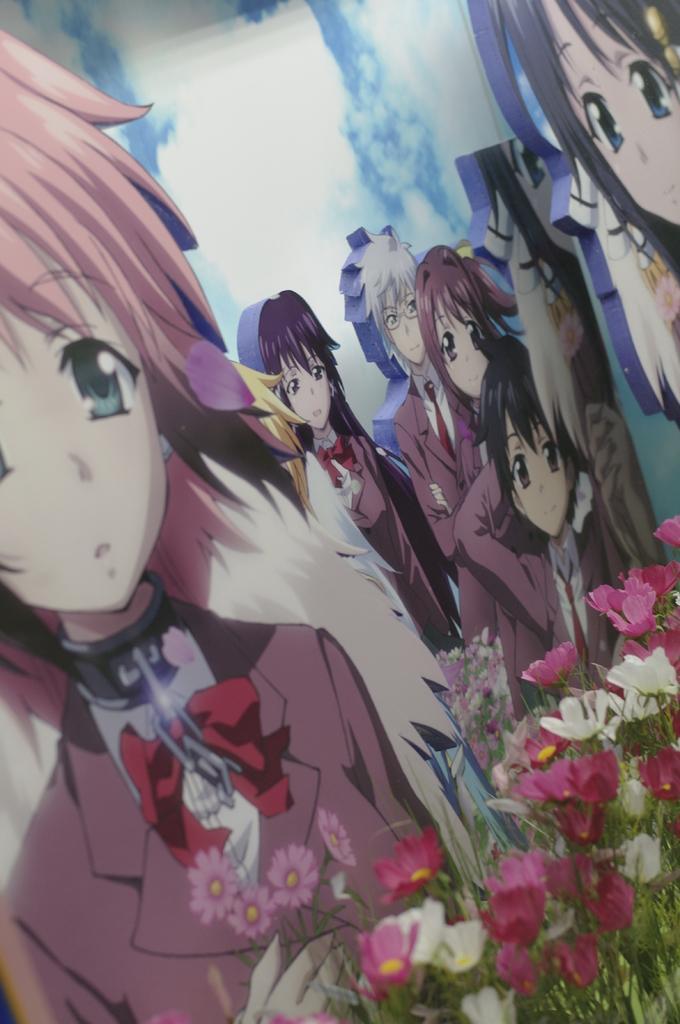Could you give a brief overview of what you see in this image? In this image we can see a painting of some people, also we can see flowers, and plants. 